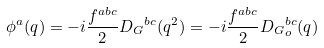Convert formula to latex. <formula><loc_0><loc_0><loc_500><loc_500>\phi ^ { a } ( q ) = - i \frac { f ^ { a b c } } { 2 } { D _ { G } } ^ { b c } ( q ^ { 2 } ) = - i \frac { f ^ { a b c } } { 2 } { D _ { G } } ^ { b c } _ { o } ( q )</formula> 